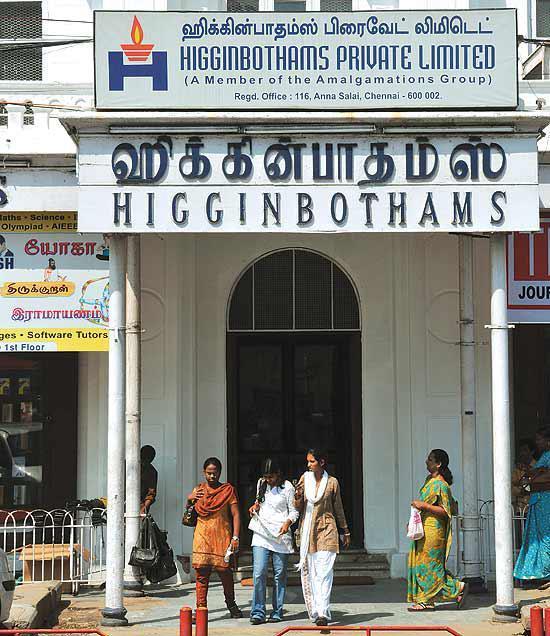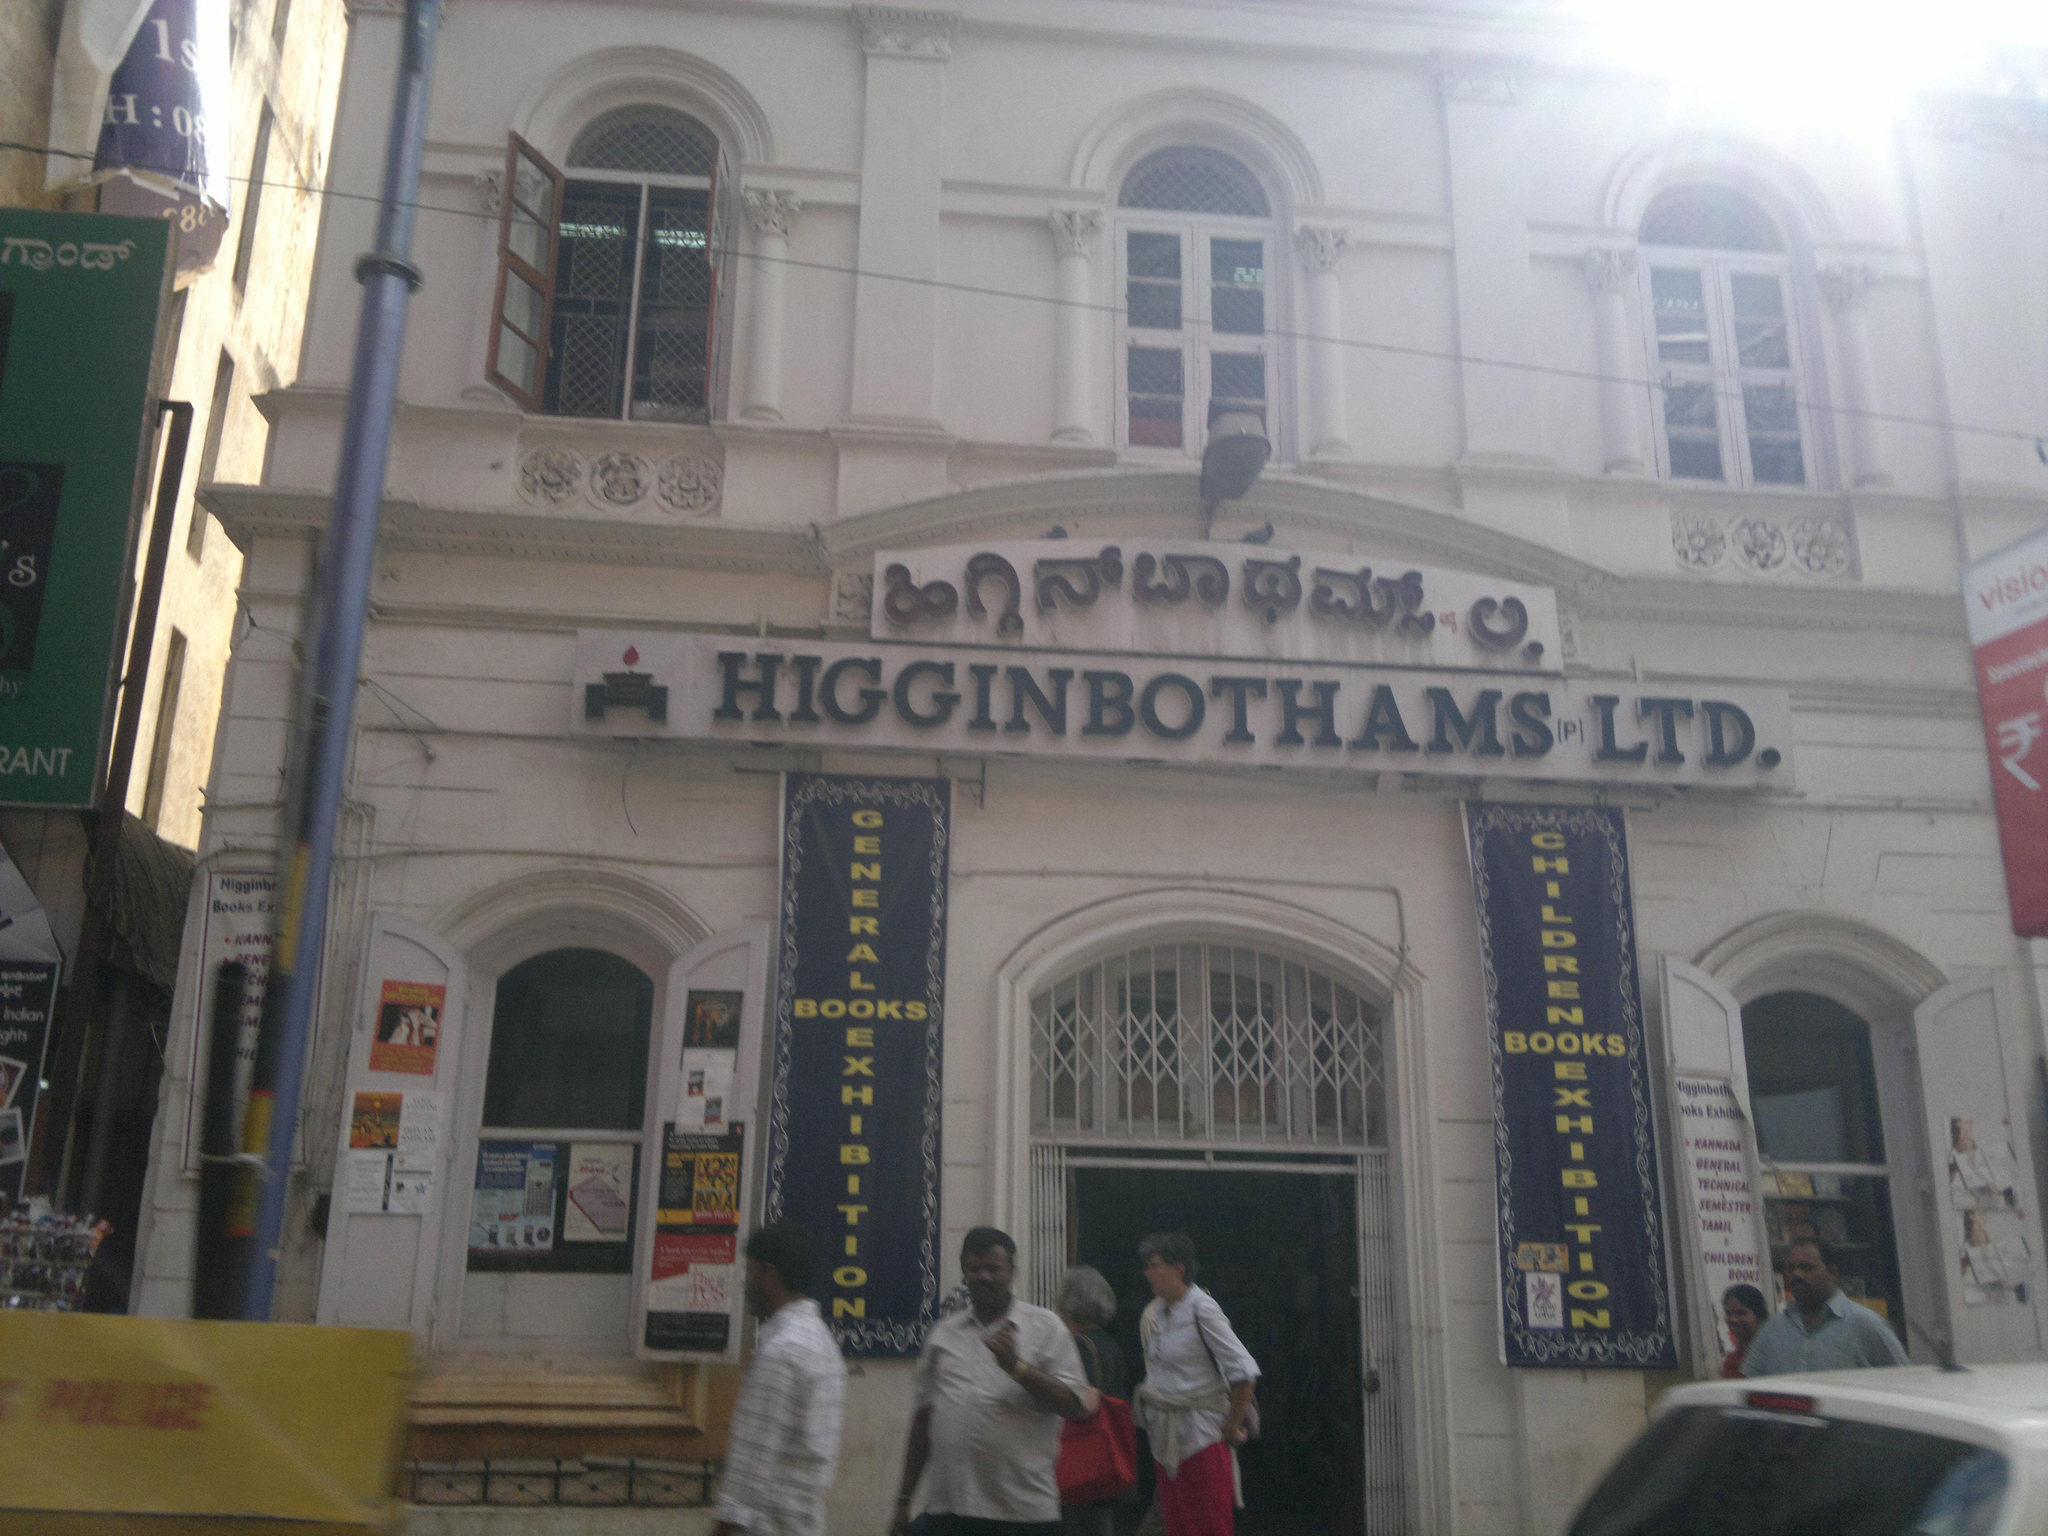The first image is the image on the left, the second image is the image on the right. Given the left and right images, does the statement "Although the image to the left is a bookstore, there are no actual books visible." hold true? Answer yes or no. Yes. The first image is the image on the left, the second image is the image on the right. For the images shown, is this caption "The right image shows an arched opening at the left end of a row of shelves in a shop's interior." true? Answer yes or no. No. 